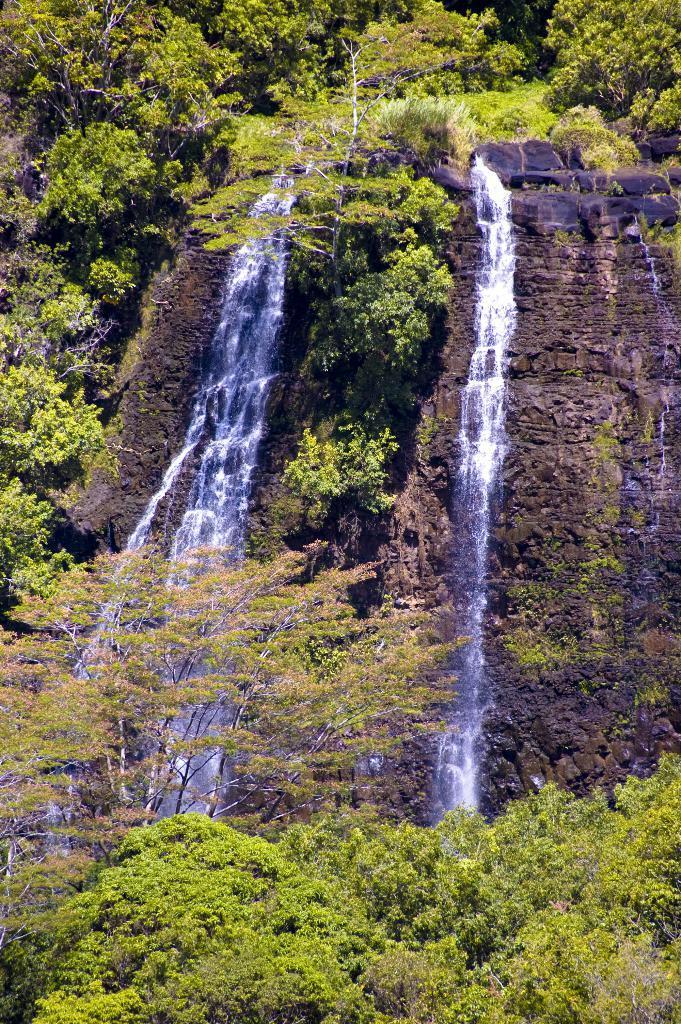Can you describe this image briefly? In this image there are trees and there is a waterfall which is visible. 